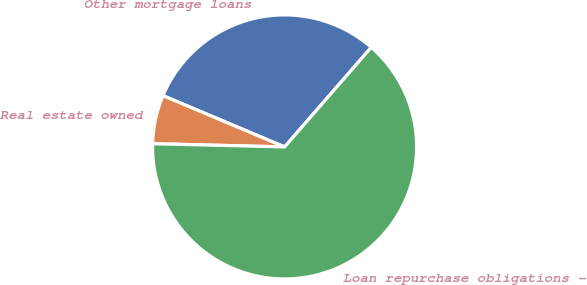<chart> <loc_0><loc_0><loc_500><loc_500><pie_chart><fcel>Other mortgage loans<fcel>Real estate owned<fcel>Loan repurchase obligations -<nl><fcel>30.05%<fcel>5.96%<fcel>63.99%<nl></chart> 